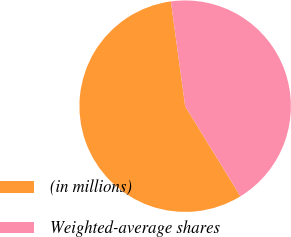Convert chart to OTSL. <chart><loc_0><loc_0><loc_500><loc_500><pie_chart><fcel>(in millions)<fcel>Weighted-average shares<nl><fcel>56.6%<fcel>43.4%<nl></chart> 